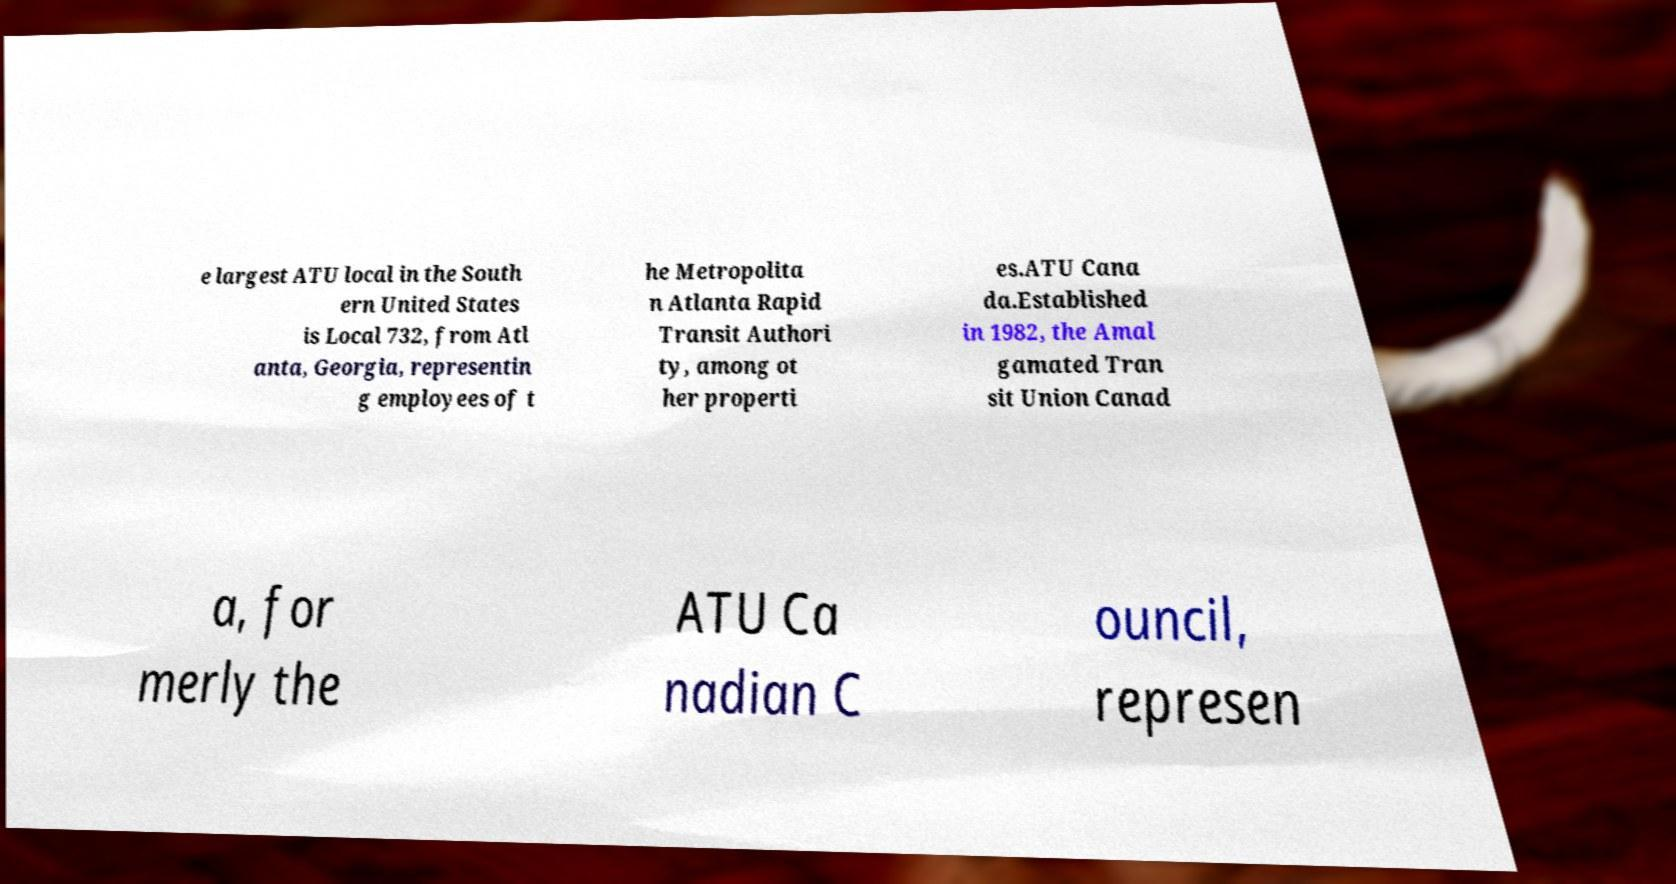Can you accurately transcribe the text from the provided image for me? e largest ATU local in the South ern United States is Local 732, from Atl anta, Georgia, representin g employees of t he Metropolita n Atlanta Rapid Transit Authori ty, among ot her properti es.ATU Cana da.Established in 1982, the Amal gamated Tran sit Union Canad a, for merly the ATU Ca nadian C ouncil, represen 